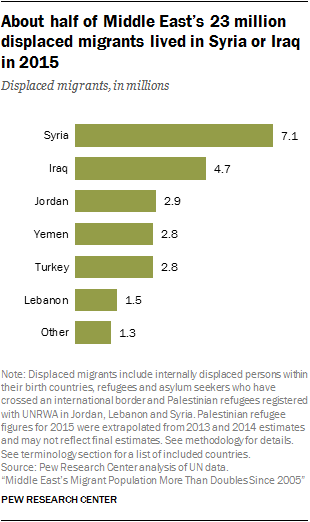Highlight a few significant elements in this photo. The value of Jordan is greater than that of Yemen. The graph shows that the highest number of displaced migrants is from the region that is represented by Syria. 